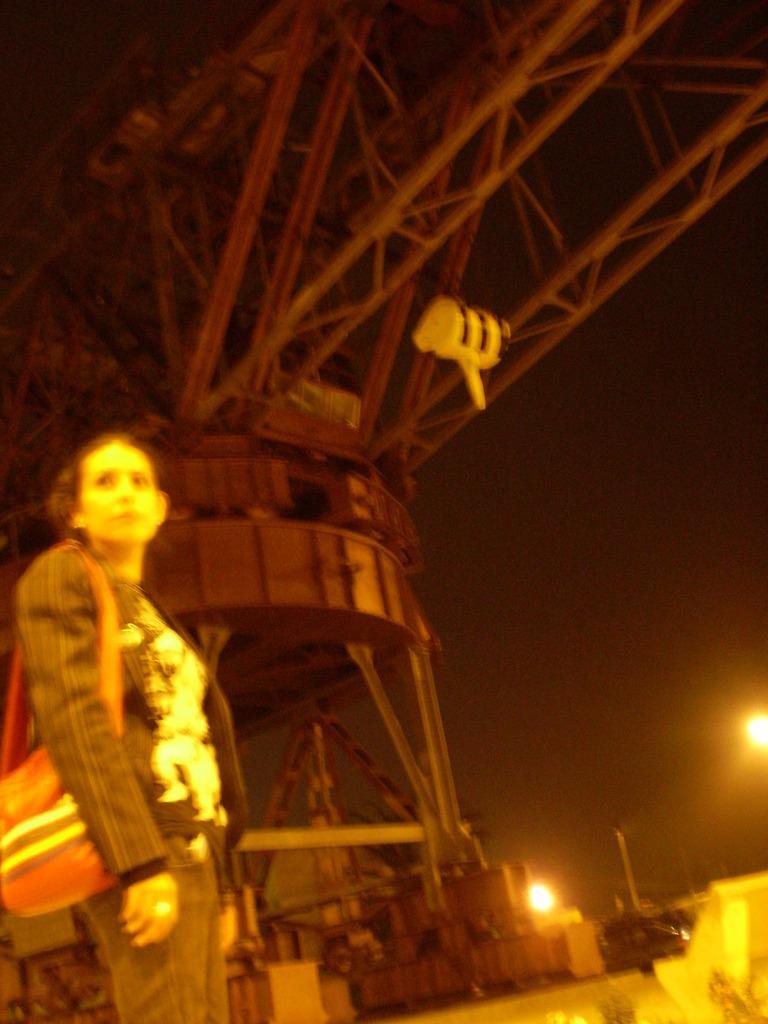Describe this image in one or two sentences. There is one woman standing on the left side is holding a bag. There is a machinery in the background, and there is a sky as we can see from the right side of this image. 